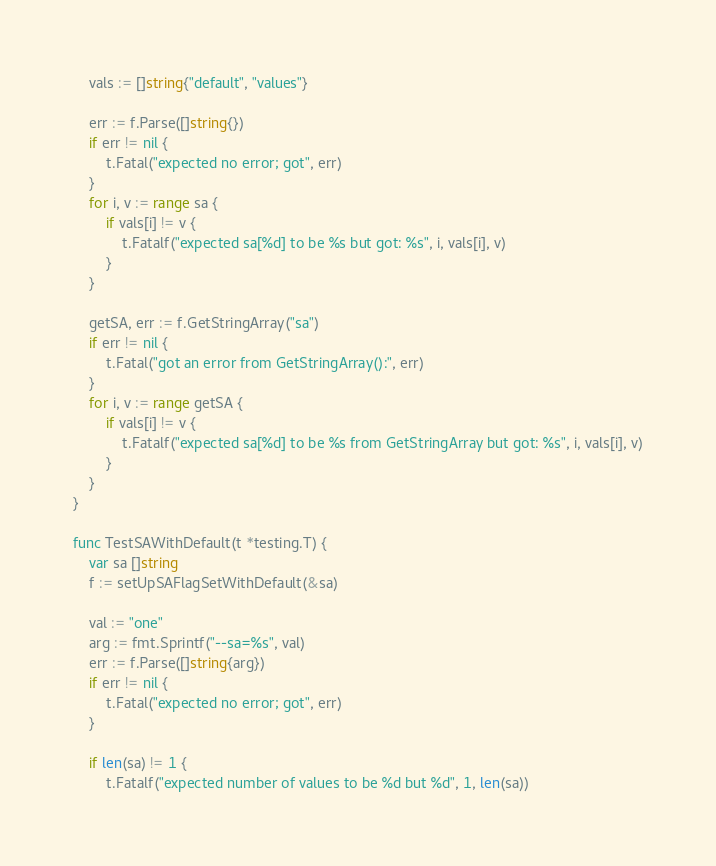Convert code to text. <code><loc_0><loc_0><loc_500><loc_500><_Go_>	vals := []string{"default", "values"}

	err := f.Parse([]string{})
	if err != nil {
		t.Fatal("expected no error; got", err)
	}
	for i, v := range sa {
		if vals[i] != v {
			t.Fatalf("expected sa[%d] to be %s but got: %s", i, vals[i], v)
		}
	}

	getSA, err := f.GetStringArray("sa")
	if err != nil {
		t.Fatal("got an error from GetStringArray():", err)
	}
	for i, v := range getSA {
		if vals[i] != v {
			t.Fatalf("expected sa[%d] to be %s from GetStringArray but got: %s", i, vals[i], v)
		}
	}
}

func TestSAWithDefault(t *testing.T) {
	var sa []string
	f := setUpSAFlagSetWithDefault(&sa)

	val := "one"
	arg := fmt.Sprintf("--sa=%s", val)
	err := f.Parse([]string{arg})
	if err != nil {
		t.Fatal("expected no error; got", err)
	}

	if len(sa) != 1 {
		t.Fatalf("expected number of values to be %d but %d", 1, len(sa))</code> 